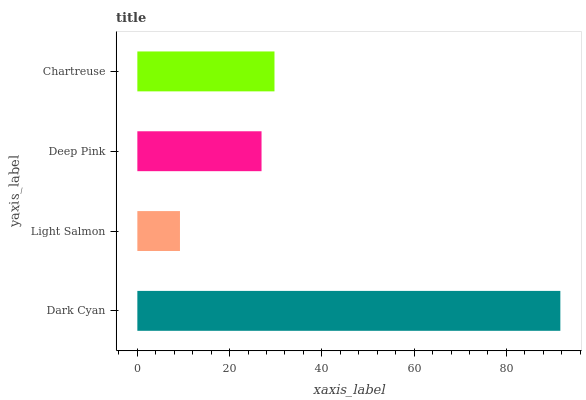Is Light Salmon the minimum?
Answer yes or no. Yes. Is Dark Cyan the maximum?
Answer yes or no. Yes. Is Deep Pink the minimum?
Answer yes or no. No. Is Deep Pink the maximum?
Answer yes or no. No. Is Deep Pink greater than Light Salmon?
Answer yes or no. Yes. Is Light Salmon less than Deep Pink?
Answer yes or no. Yes. Is Light Salmon greater than Deep Pink?
Answer yes or no. No. Is Deep Pink less than Light Salmon?
Answer yes or no. No. Is Chartreuse the high median?
Answer yes or no. Yes. Is Deep Pink the low median?
Answer yes or no. Yes. Is Deep Pink the high median?
Answer yes or no. No. Is Chartreuse the low median?
Answer yes or no. No. 